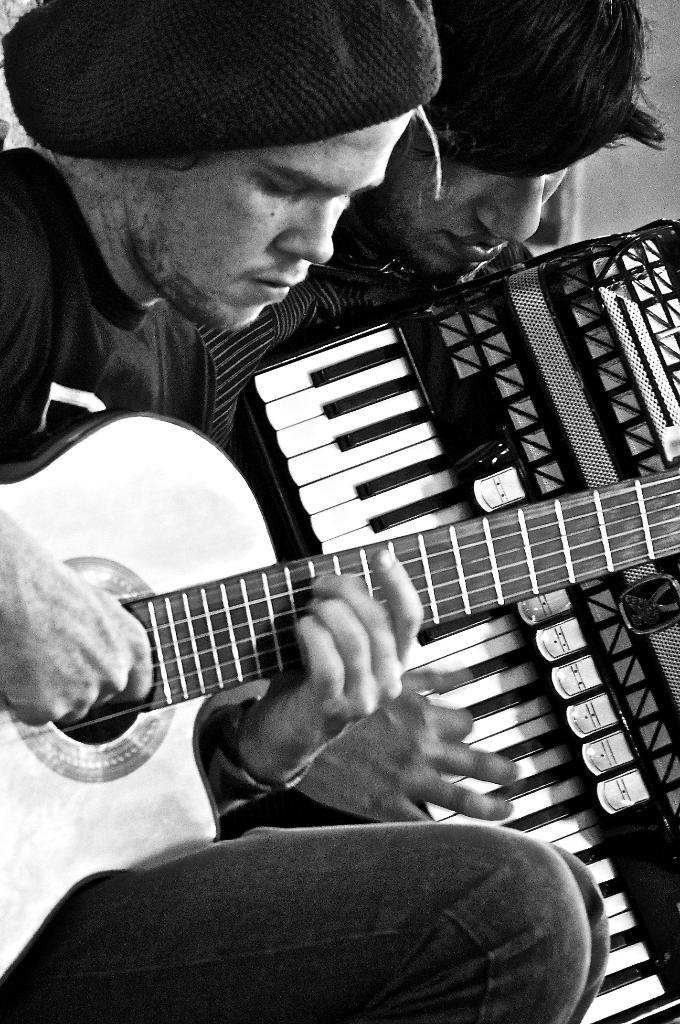What is the color scheme of the image? The image is black and white. How many people are in the image? There are two men in the image. What are the men holding in the image? The men are holding music instruments. Can you see a star in the image? There is no star present in the image; it is a black and white image of two men holding music instruments. 